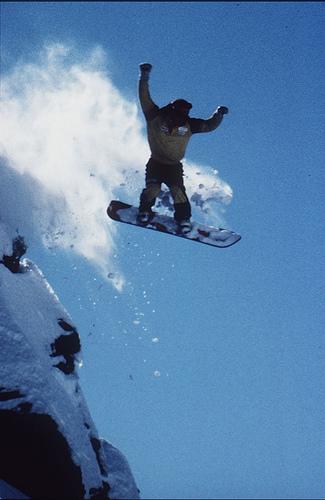What color are the man's pants?
Be succinct. Black. What is this man riding?
Quick response, please. Snowboard. What is the man wearing?
Keep it brief. Snowsuit. Is the man on the ground?
Answer briefly. No. What sport is this man doing?
Short answer required. Snowboarding. Is this man going down the mountain?
Write a very short answer. Yes. What is in the air?
Keep it brief. Snowboarder. Is the man literally smoking?
Write a very short answer. No. 